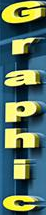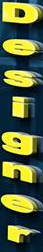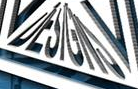What words are shown in these images in order, separated by a semicolon? Graphic; Designer; DESIGNS 